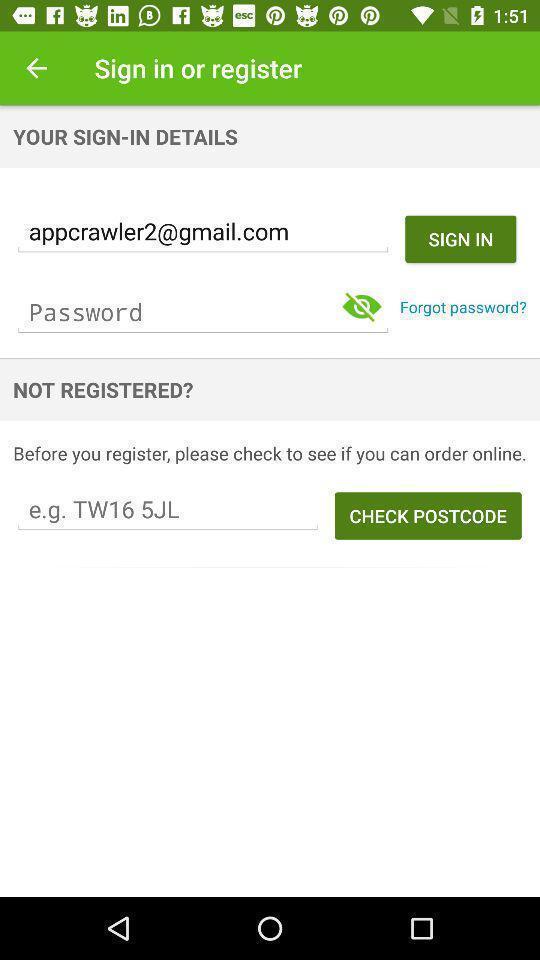Give me a summary of this screen capture. Sign in page. 